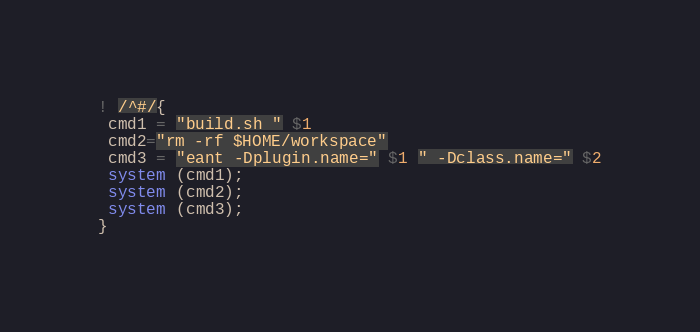Convert code to text. <code><loc_0><loc_0><loc_500><loc_500><_Awk_>! /^#/{
 cmd1 = "build.sh " $1
 cmd2="rm -rf $HOME/workspace"
 cmd3 = "eant -Dplugin.name=" $1 " -Dclass.name=" $2
 system (cmd1);
 system (cmd2);
 system (cmd3);
}
</code> 